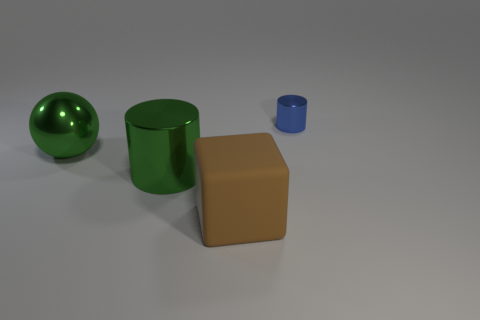Add 4 tiny green matte blocks. How many objects exist? 8 Subtract all gray cylinders. Subtract all brown cubes. How many cylinders are left? 2 Subtract all blue blocks. How many brown cylinders are left? 0 Subtract all large green shiny cylinders. Subtract all metallic balls. How many objects are left? 2 Add 2 big green spheres. How many big green spheres are left? 3 Add 4 large metallic cylinders. How many large metallic cylinders exist? 5 Subtract 0 blue spheres. How many objects are left? 4 Subtract all cubes. How many objects are left? 3 Subtract 1 cylinders. How many cylinders are left? 1 